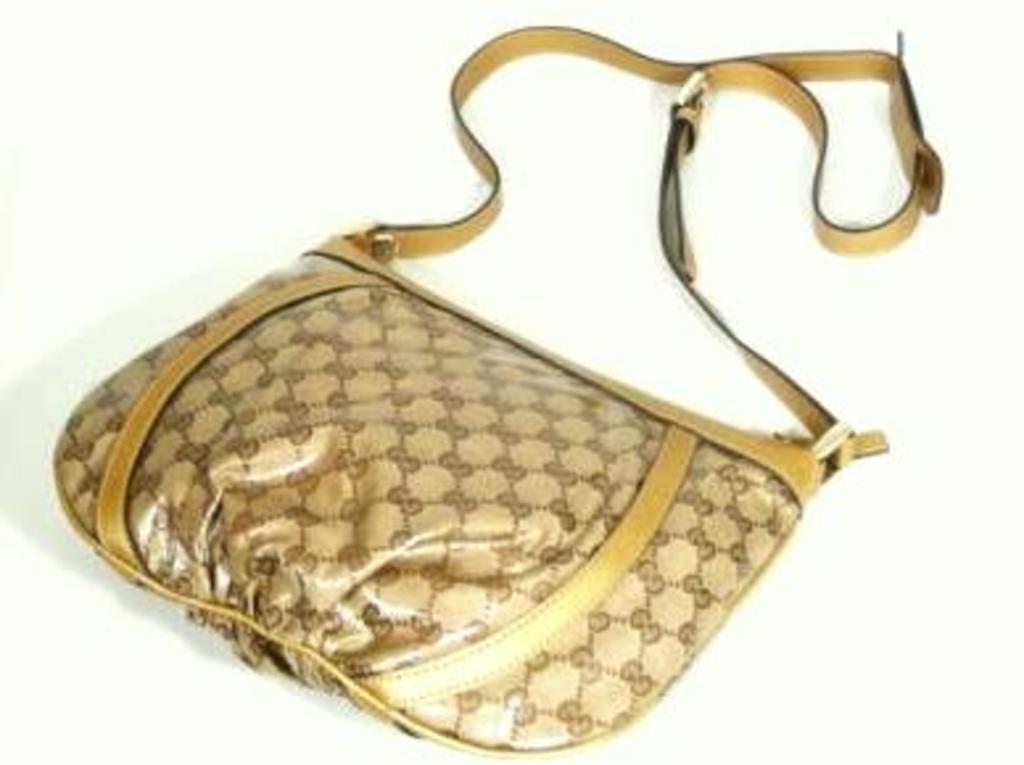Can you describe this image briefly? There is a brown bag with yellow stripes is kept on a white surface. 